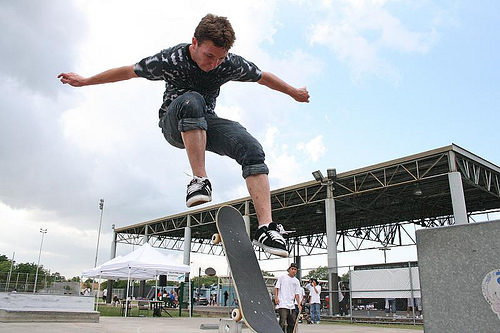<image>
Can you confirm if the men is above the board? Yes. The men is positioned above the board in the vertical space, higher up in the scene. 